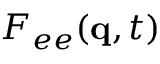Convert formula to latex. <formula><loc_0><loc_0><loc_500><loc_500>F _ { e e } ( q , t )</formula> 